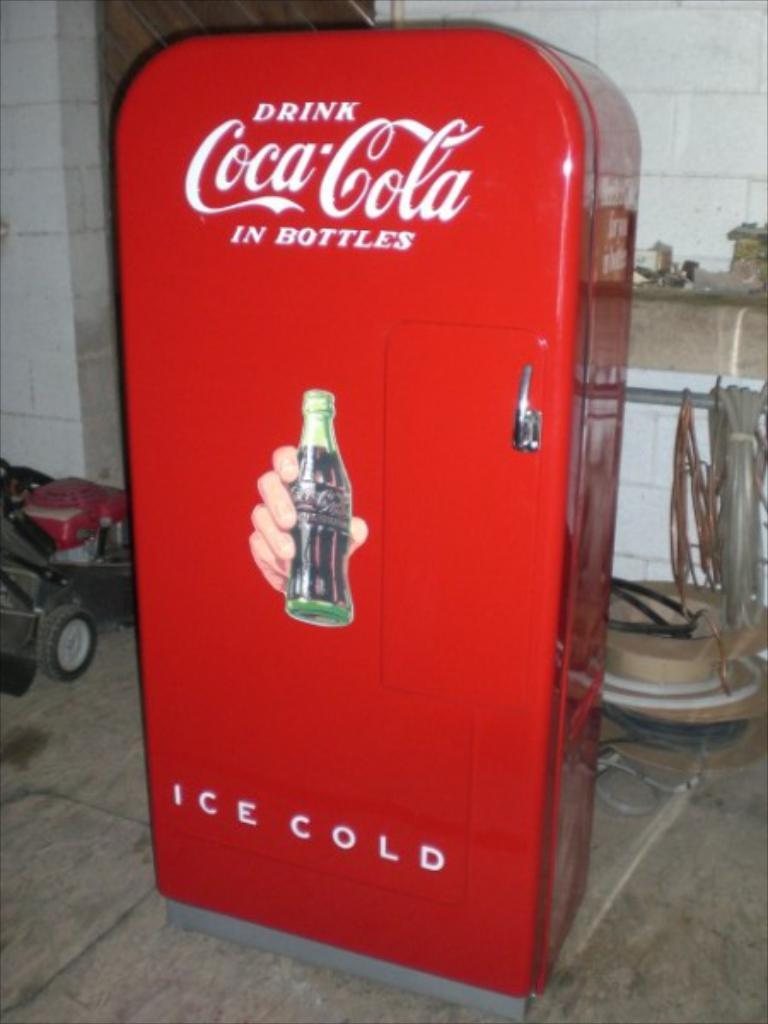What type of machine is present in the image? There is a soft drink vending machine in the image. What is located behind the vending machine? There is a wooden table behind the vending machine. What other type of machine can be seen in the image? There is a garden cutting machine on the left side of the image. What time of day is it in the image, and can you hear the wind blowing through the ear of the person in the image? There is no person present in the image, and the time of day cannot be determined from the image. Additionally, the wind cannot be heard blowing through an ear in the image, as there is no ear or person depicted. 